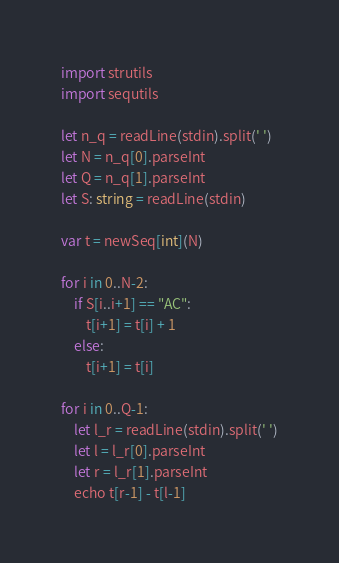<code> <loc_0><loc_0><loc_500><loc_500><_Nim_>import strutils
import sequtils

let n_q = readLine(stdin).split(' ')
let N = n_q[0].parseInt
let Q = n_q[1].parseInt
let S: string = readLine(stdin)

var t = newSeq[int](N)

for i in 0..N-2:
    if S[i..i+1] == "AC":
        t[i+1] = t[i] + 1
    else:
        t[i+1] = t[i]

for i in 0..Q-1:
    let l_r = readLine(stdin).split(' ')
    let l = l_r[0].parseInt
    let r = l_r[1].parseInt
    echo t[r-1] - t[l-1]
</code> 